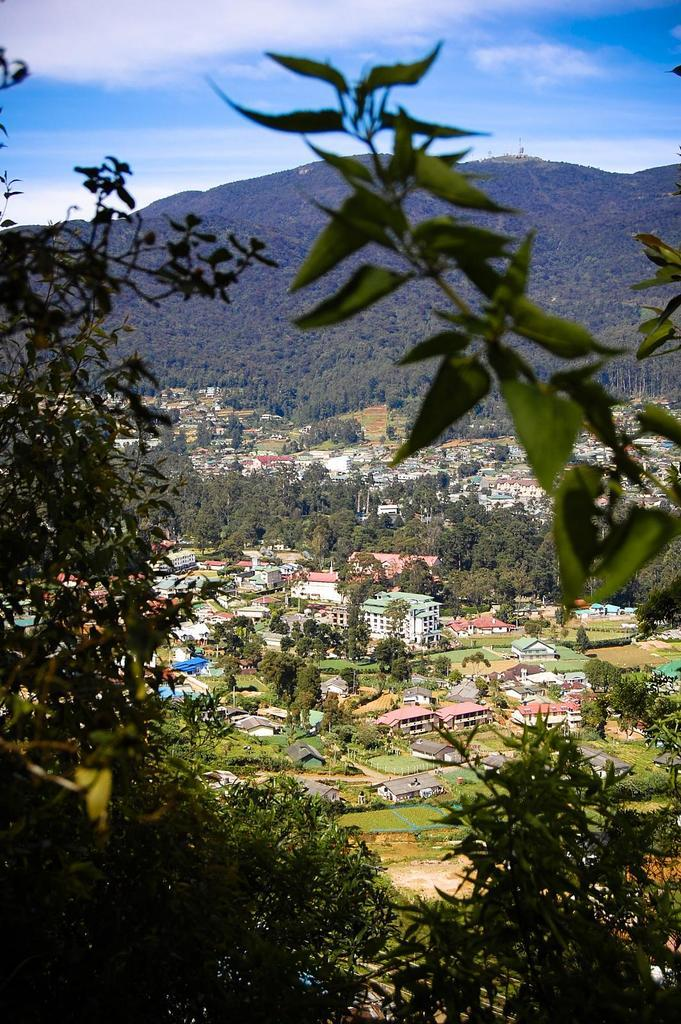What type of vegetation can be seen in the image? There are plants in the image. What can be seen behind the plants? There are many trees behind the plants. What structures are visible in the background of the image? There are houses and buildings in the background of the image. What natural feature can be seen in the distance? There is a mountain visible in the background of the image. How many pins are holding the patch on the mountain in the image? There are no pins or patches present on the mountain in the image. 